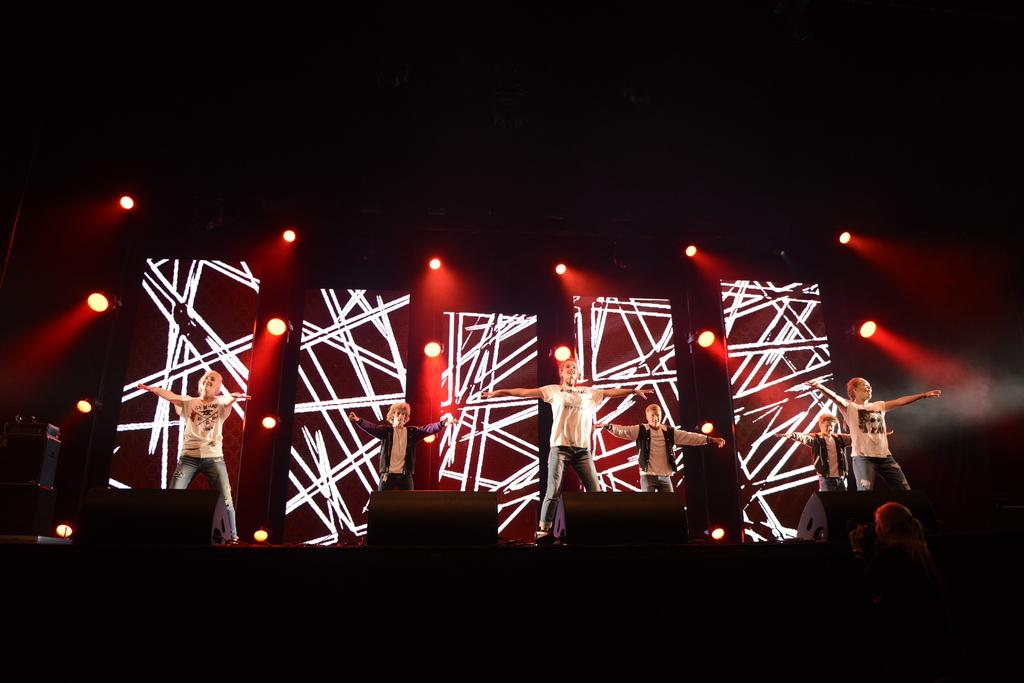What is happening on the stage in the image? There are people standing on the stage in the image. What can be seen in the background of the stage? Stage lights are visible in the background. Are there any other objects or items on the stage? Yes, there are other objects on the stage. What type of berry is being used as a prop on the stage? There is no berry present on the stage in the image. What bedroom furniture can be seen in the image? The image does not depict a bedroom, so there is no bedroom furniture present. 